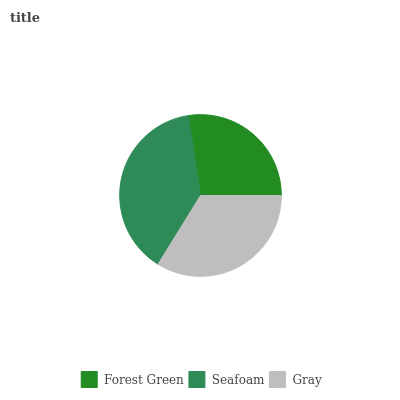Is Forest Green the minimum?
Answer yes or no. Yes. Is Seafoam the maximum?
Answer yes or no. Yes. Is Gray the minimum?
Answer yes or no. No. Is Gray the maximum?
Answer yes or no. No. Is Seafoam greater than Gray?
Answer yes or no. Yes. Is Gray less than Seafoam?
Answer yes or no. Yes. Is Gray greater than Seafoam?
Answer yes or no. No. Is Seafoam less than Gray?
Answer yes or no. No. Is Gray the high median?
Answer yes or no. Yes. Is Gray the low median?
Answer yes or no. Yes. Is Seafoam the high median?
Answer yes or no. No. Is Forest Green the low median?
Answer yes or no. No. 